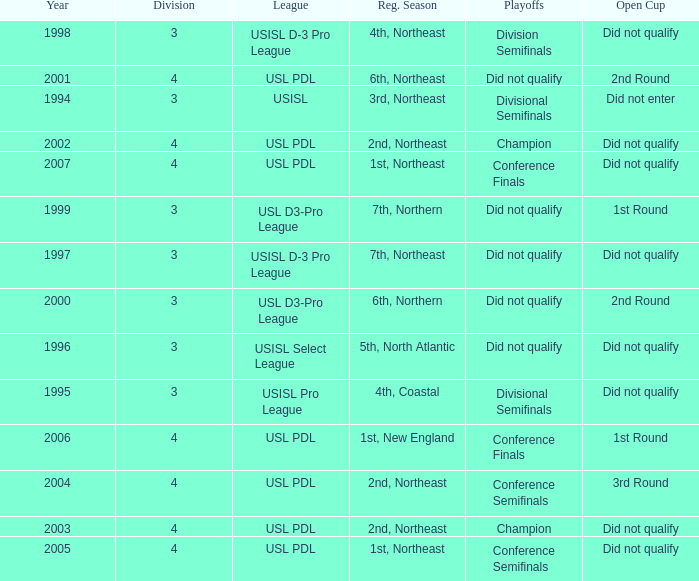Name the playoffs for  usisl select league Did not qualify. 